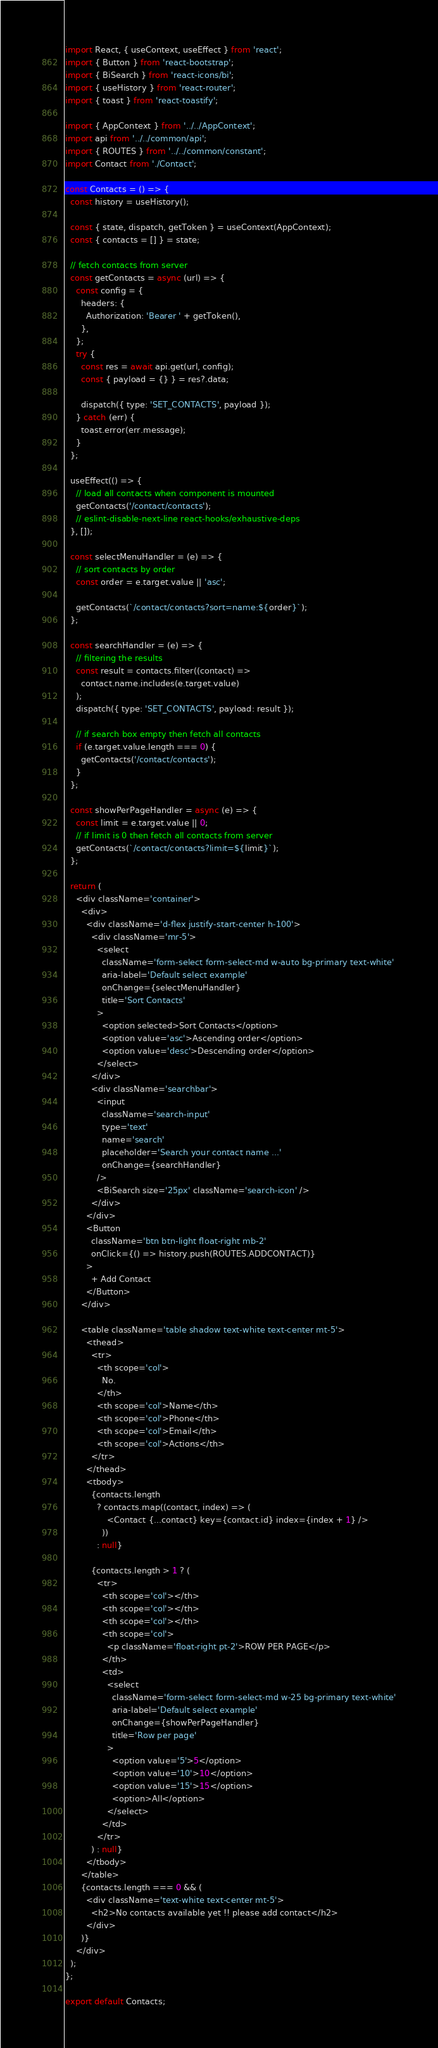<code> <loc_0><loc_0><loc_500><loc_500><_JavaScript_>import React, { useContext, useEffect } from 'react';
import { Button } from 'react-bootstrap';
import { BiSearch } from 'react-icons/bi';
import { useHistory } from 'react-router';
import { toast } from 'react-toastify';

import { AppContext } from '../../AppContext';
import api from '../../common/api';
import { ROUTES } from '../../common/constant';
import Contact from './Contact';

const Contacts = () => {
  const history = useHistory();

  const { state, dispatch, getToken } = useContext(AppContext);
  const { contacts = [] } = state;

  // fetch contacts from server
  const getContacts = async (url) => {
    const config = {
      headers: {
        Authorization: 'Bearer ' + getToken(),
      },
    };
    try {
      const res = await api.get(url, config);
      const { payload = {} } = res?.data;

      dispatch({ type: 'SET_CONTACTS', payload });
    } catch (err) {
      toast.error(err.message);
    }
  };

  useEffect(() => {
    // load all contacts when component is mounted
    getContacts('/contact/contacts');
    // eslint-disable-next-line react-hooks/exhaustive-deps
  }, []);

  const selectMenuHandler = (e) => {
    // sort contacts by order
    const order = e.target.value || 'asc';

    getContacts(`/contact/contacts?sort=name:${order}`);
  };

  const searchHandler = (e) => {
    // filtering the results
    const result = contacts.filter((contact) =>
      contact.name.includes(e.target.value)
    );
    dispatch({ type: 'SET_CONTACTS', payload: result });

    // if search box empty then fetch all contacts
    if (e.target.value.length === 0) {
      getContacts('/contact/contacts');
    }
  };

  const showPerPageHandler = async (e) => {
    const limit = e.target.value || 0;
    // if limit is 0 then fetch all contacts from server
    getContacts(`/contact/contacts?limit=${limit}`);
  };

  return (
    <div className='container'>
      <div>
        <div className='d-flex justify-start-center h-100'>
          <div className='mr-5'>
            <select
              className='form-select form-select-md w-auto bg-primary text-white'
              aria-label='Default select example'
              onChange={selectMenuHandler}
              title='Sort Contacts'
            >
              <option selected>Sort Contacts</option>
              <option value='asc'>Ascending order</option>
              <option value='desc'>Descending order</option>
            </select>
          </div>
          <div className='searchbar'>
            <input
              className='search-input'
              type='text'
              name='search'
              placeholder='Search your contact name ...'
              onChange={searchHandler}
            />
            <BiSearch size='25px' className='search-icon' />
          </div>
        </div>
        <Button
          className='btn btn-light float-right mb-2'
          onClick={() => history.push(ROUTES.ADDCONTACT)}
        >
          + Add Contact
        </Button>
      </div>

      <table className='table shadow text-white text-center mt-5'>
        <thead>
          <tr>
            <th scope='col'>
              No.
            </th>
            <th scope='col'>Name</th>
            <th scope='col'>Phone</th>
            <th scope='col'>Email</th>
            <th scope='col'>Actions</th>
          </tr>
        </thead>
        <tbody>
          {contacts.length
            ? contacts.map((contact, index) => (
                <Contact {...contact} key={contact.id} index={index + 1} />
              ))
            : null}

          {contacts.length > 1 ? (
            <tr>
              <th scope='col'></th>
              <th scope='col'></th>
              <th scope='col'></th>
              <th scope='col'>
                <p className='float-right pt-2'>ROW PER PAGE</p>
              </th>
              <td>
                <select
                  className='form-select form-select-md w-25 bg-primary text-white'
                  aria-label='Default select example'
                  onChange={showPerPageHandler}
                  title='Row per page'
                >
                  <option value='5'>5</option>
                  <option value='10'>10</option>
                  <option value='15'>15</option>
                  <option>All</option>
                </select>
              </td>
            </tr>
          ) : null}
        </tbody>
      </table>
      {contacts.length === 0 && (
        <div className='text-white text-center mt-5'>
          <h2>No contacts available yet !! please add contact</h2>
        </div>
      )}
    </div>
  );
};

export default Contacts;
</code> 